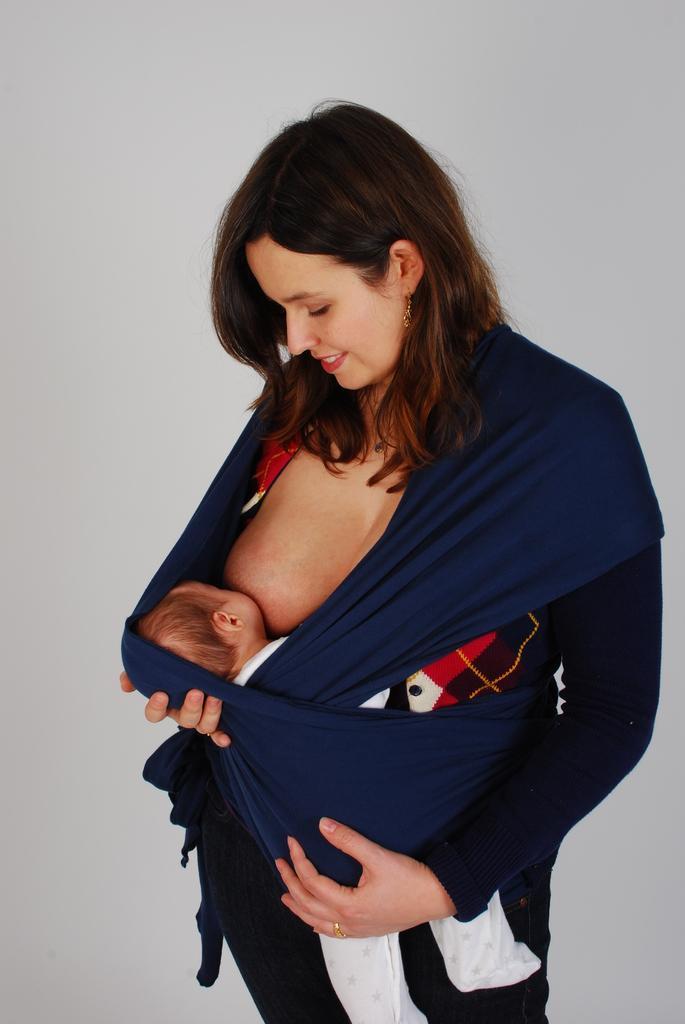Describe this image in one or two sentences. In this image there is a woman feeding her child. Behind her there is a wall. 